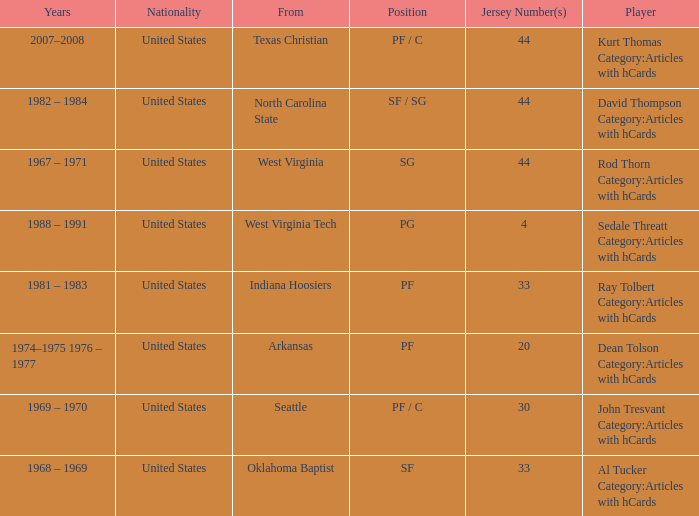What was the highest jersey number for the player from oklahoma baptist? 33.0. Could you parse the entire table as a dict? {'header': ['Years', 'Nationality', 'From', 'Position', 'Jersey Number(s)', 'Player'], 'rows': [['2007–2008', 'United States', 'Texas Christian', 'PF / C', '44', 'Kurt Thomas Category:Articles with hCards'], ['1982 – 1984', 'United States', 'North Carolina State', 'SF / SG', '44', 'David Thompson Category:Articles with hCards'], ['1967 – 1971', 'United States', 'West Virginia', 'SG', '44', 'Rod Thorn Category:Articles with hCards'], ['1988 – 1991', 'United States', 'West Virginia Tech', 'PG', '4', 'Sedale Threatt Category:Articles with hCards'], ['1981 – 1983', 'United States', 'Indiana Hoosiers', 'PF', '33', 'Ray Tolbert Category:Articles with hCards'], ['1974–1975 1976 – 1977', 'United States', 'Arkansas', 'PF', '20', 'Dean Tolson Category:Articles with hCards'], ['1969 – 1970', 'United States', 'Seattle', 'PF / C', '30', 'John Tresvant Category:Articles with hCards'], ['1968 – 1969', 'United States', 'Oklahoma Baptist', 'SF', '33', 'Al Tucker Category:Articles with hCards']]} 